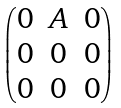Convert formula to latex. <formula><loc_0><loc_0><loc_500><loc_500>\begin{pmatrix} 0 & A & 0 \\ 0 & 0 & 0 \\ 0 & 0 & 0 \\ \end{pmatrix}</formula> 